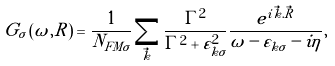<formula> <loc_0><loc_0><loc_500><loc_500>\tilde { G } _ { \sigma } \left ( \omega , R \right ) = \frac { 1 } { N _ { F M \sigma } } \sum _ { \vec { k } } \frac { \Gamma ^ { 2 } } { \Gamma ^ { 2 } + \varepsilon _ { k \sigma } ^ { 2 } } \frac { e ^ { i \vec { k } . \vec { R } } } { \omega - \varepsilon _ { k \sigma } - i \eta } ,</formula> 